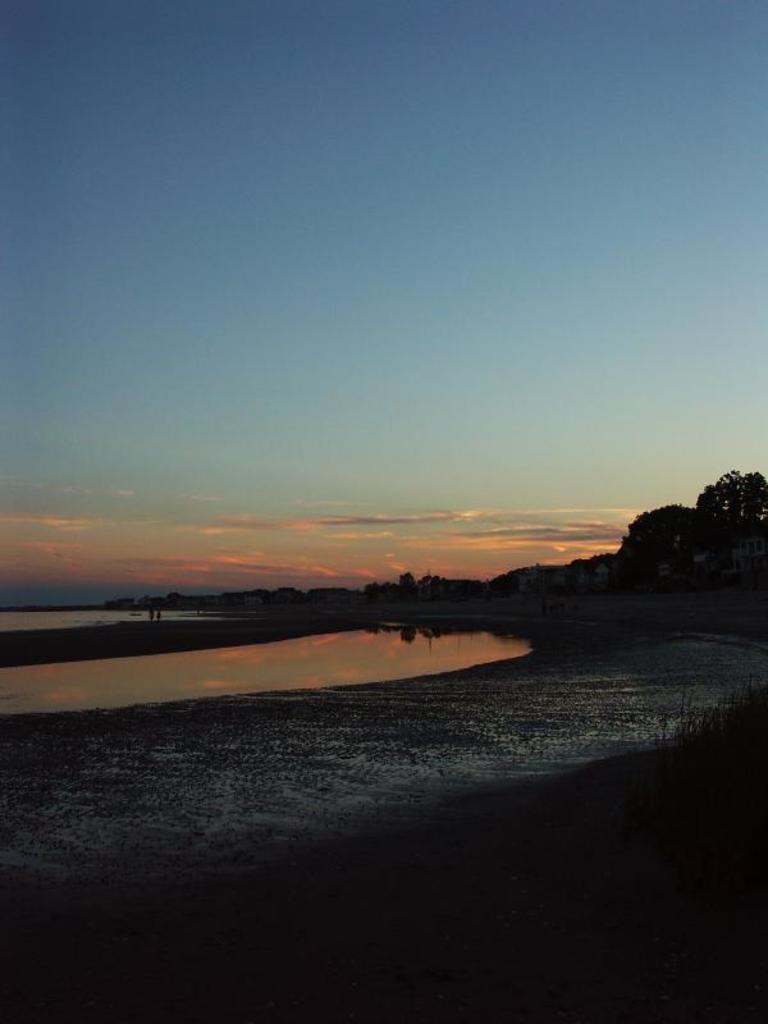Could you give a brief overview of what you see in this image? In this image I can see the ground, the water, few buildings and few trees. In the background I can see the sky. 